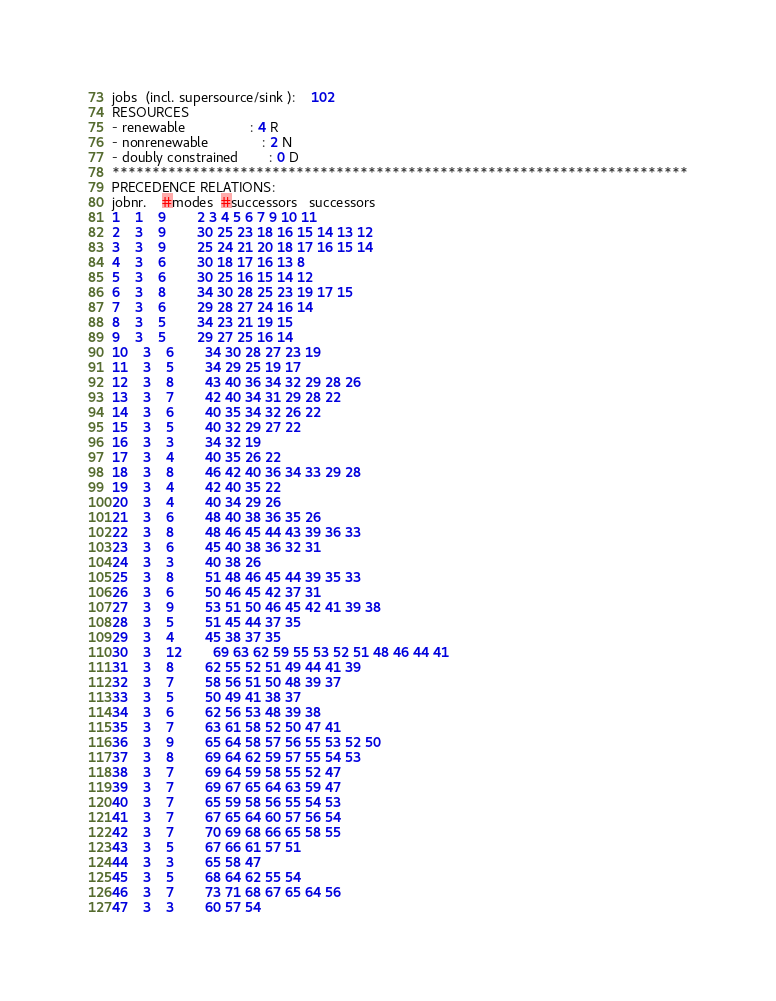<code> <loc_0><loc_0><loc_500><loc_500><_ObjectiveC_>jobs  (incl. supersource/sink ):	102
RESOURCES
- renewable                 : 4 R
- nonrenewable              : 2 N
- doubly constrained        : 0 D
************************************************************************
PRECEDENCE RELATIONS:
jobnr.    #modes  #successors   successors
1	1	9		2 3 4 5 6 7 9 10 11 
2	3	9		30 25 23 18 16 15 14 13 12 
3	3	9		25 24 21 20 18 17 16 15 14 
4	3	6		30 18 17 16 13 8 
5	3	6		30 25 16 15 14 12 
6	3	8		34 30 28 25 23 19 17 15 
7	3	6		29 28 27 24 16 14 
8	3	5		34 23 21 19 15 
9	3	5		29 27 25 16 14 
10	3	6		34 30 28 27 23 19 
11	3	5		34 29 25 19 17 
12	3	8		43 40 36 34 32 29 28 26 
13	3	7		42 40 34 31 29 28 22 
14	3	6		40 35 34 32 26 22 
15	3	5		40 32 29 27 22 
16	3	3		34 32 19 
17	3	4		40 35 26 22 
18	3	8		46 42 40 36 34 33 29 28 
19	3	4		42 40 35 22 
20	3	4		40 34 29 26 
21	3	6		48 40 38 36 35 26 
22	3	8		48 46 45 44 43 39 36 33 
23	3	6		45 40 38 36 32 31 
24	3	3		40 38 26 
25	3	8		51 48 46 45 44 39 35 33 
26	3	6		50 46 45 42 37 31 
27	3	9		53 51 50 46 45 42 41 39 38 
28	3	5		51 45 44 37 35 
29	3	4		45 38 37 35 
30	3	12		69 63 62 59 55 53 52 51 48 46 44 41 
31	3	8		62 55 52 51 49 44 41 39 
32	3	7		58 56 51 50 48 39 37 
33	3	5		50 49 41 38 37 
34	3	6		62 56 53 48 39 38 
35	3	7		63 61 58 52 50 47 41 
36	3	9		65 64 58 57 56 55 53 52 50 
37	3	8		69 64 62 59 57 55 54 53 
38	3	7		69 64 59 58 55 52 47 
39	3	7		69 67 65 64 63 59 47 
40	3	7		65 59 58 56 55 54 53 
41	3	7		67 65 64 60 57 56 54 
42	3	7		70 69 68 66 65 58 55 
43	3	5		67 66 61 57 51 
44	3	3		65 58 47 
45	3	5		68 64 62 55 54 
46	3	7		73 71 68 67 65 64 56 
47	3	3		60 57 54 </code> 